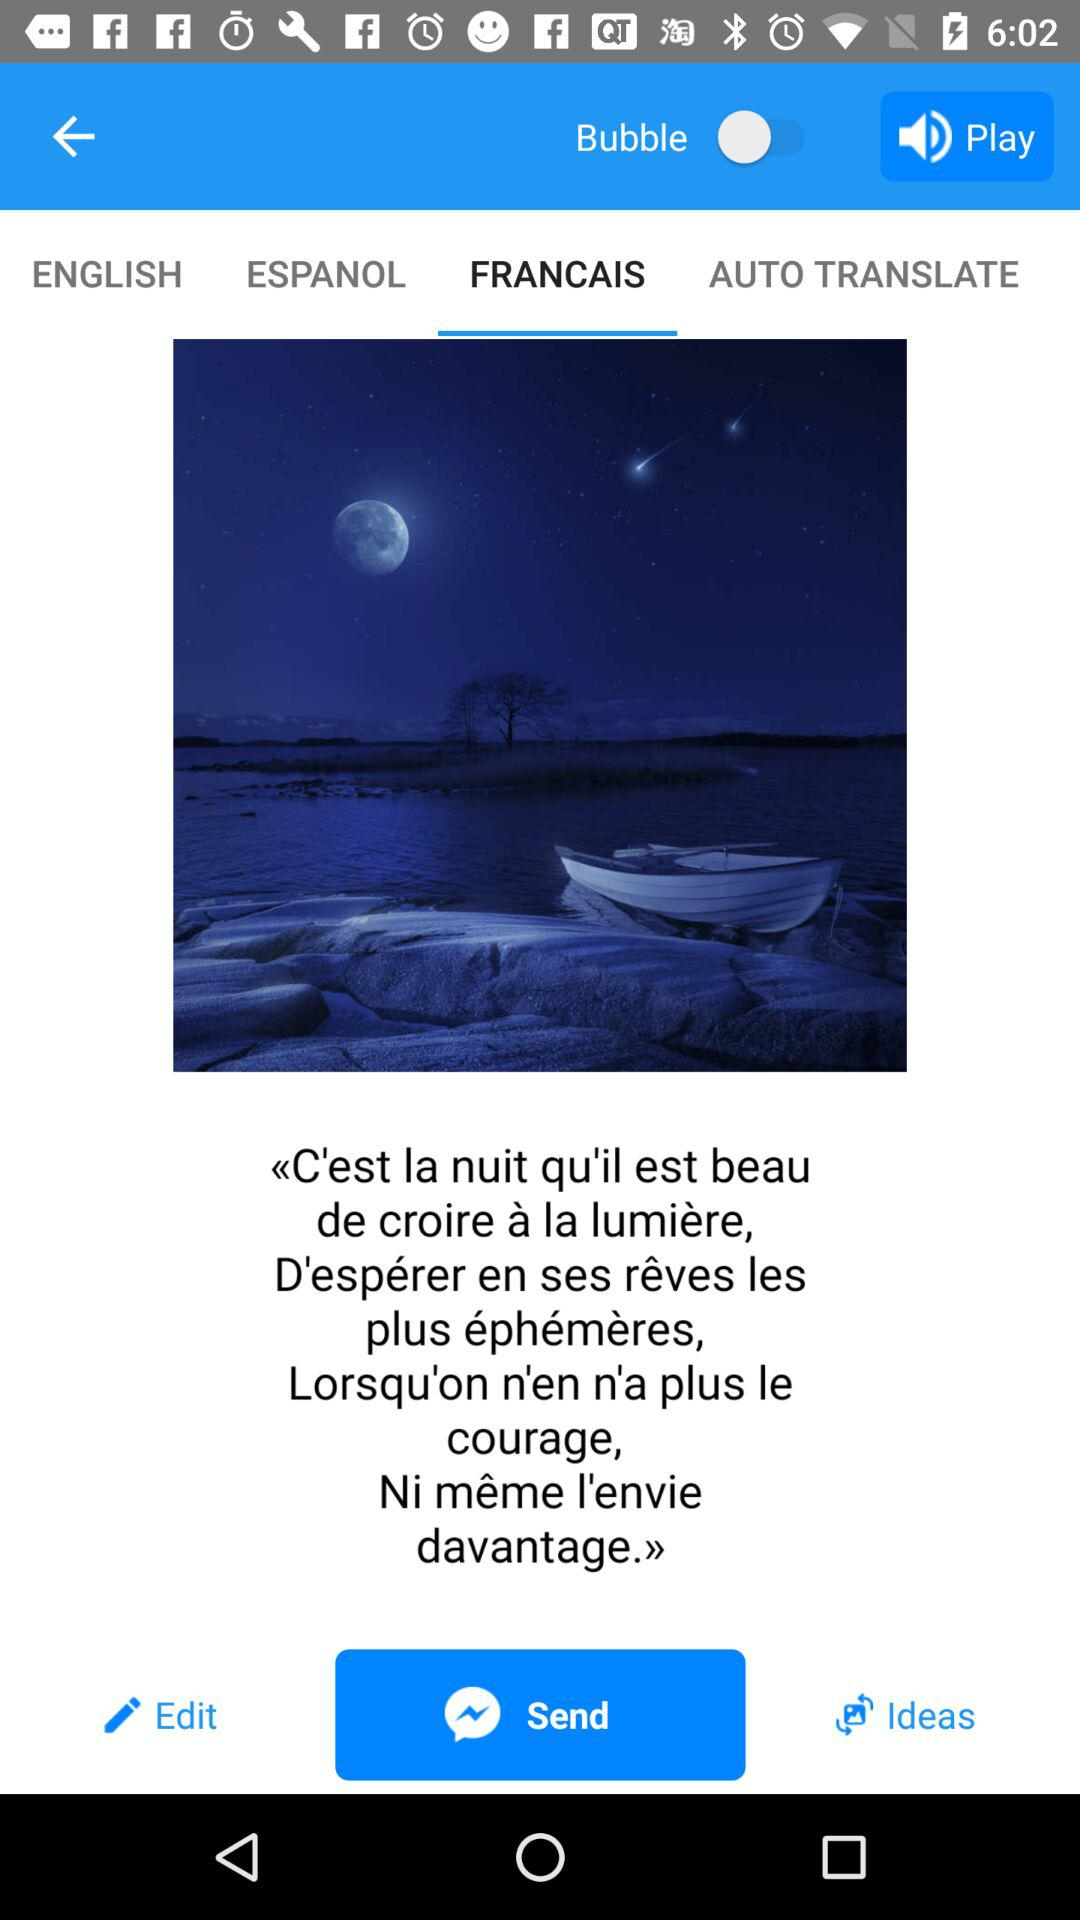Which option has been selected? The selected options are "FRANCAIS" and "Send". 